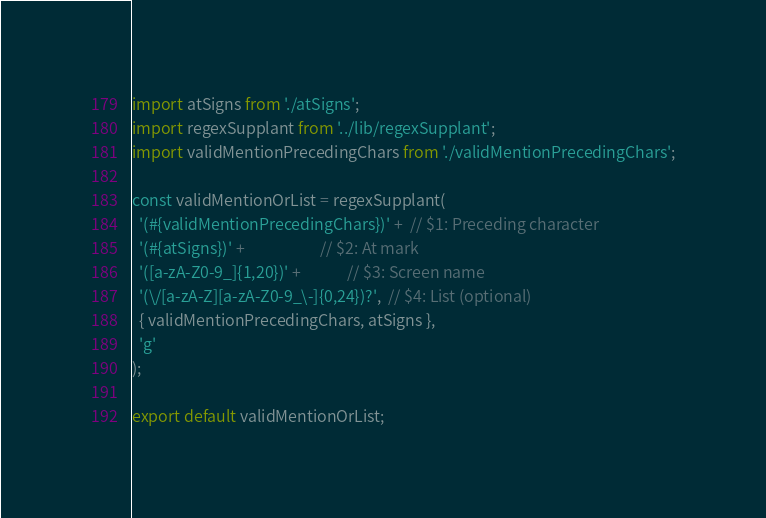<code> <loc_0><loc_0><loc_500><loc_500><_JavaScript_>import atSigns from './atSigns';
import regexSupplant from '../lib/regexSupplant';
import validMentionPrecedingChars from './validMentionPrecedingChars';

const validMentionOrList = regexSupplant(
  '(#{validMentionPrecedingChars})' +  // $1: Preceding character
  '(#{atSigns})' +                     // $2: At mark
  '([a-zA-Z0-9_]{1,20})' +             // $3: Screen name
  '(\/[a-zA-Z][a-zA-Z0-9_\-]{0,24})?',  // $4: List (optional)
  { validMentionPrecedingChars, atSigns },
  'g'
);

export default validMentionOrList;
</code> 